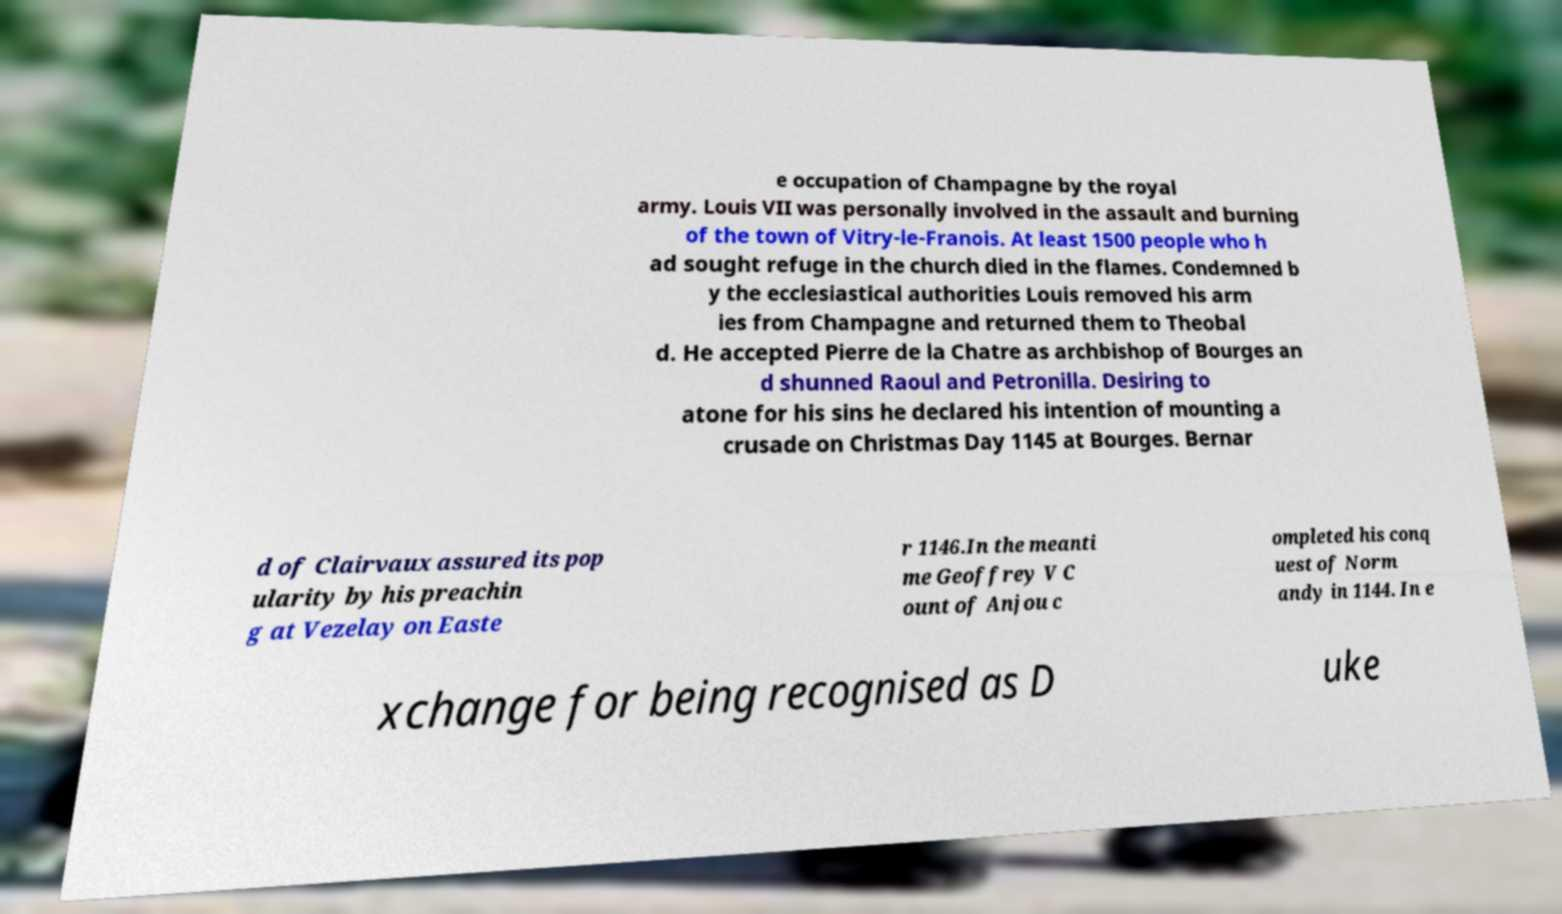Please identify and transcribe the text found in this image. e occupation of Champagne by the royal army. Louis VII was personally involved in the assault and burning of the town of Vitry-le-Franois. At least 1500 people who h ad sought refuge in the church died in the flames. Condemned b y the ecclesiastical authorities Louis removed his arm ies from Champagne and returned them to Theobal d. He accepted Pierre de la Chatre as archbishop of Bourges an d shunned Raoul and Petronilla. Desiring to atone for his sins he declared his intention of mounting a crusade on Christmas Day 1145 at Bourges. Bernar d of Clairvaux assured its pop ularity by his preachin g at Vezelay on Easte r 1146.In the meanti me Geoffrey V C ount of Anjou c ompleted his conq uest of Norm andy in 1144. In e xchange for being recognised as D uke 